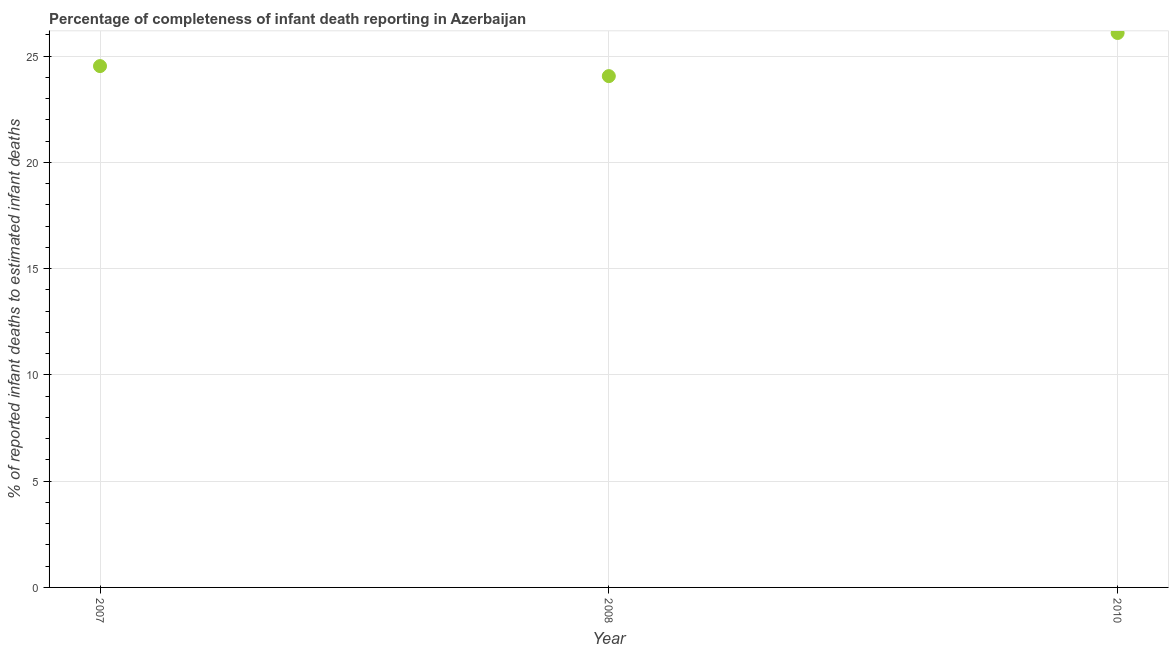What is the completeness of infant death reporting in 2007?
Your answer should be compact. 24.53. Across all years, what is the maximum completeness of infant death reporting?
Ensure brevity in your answer.  26.09. Across all years, what is the minimum completeness of infant death reporting?
Give a very brief answer. 24.06. What is the sum of the completeness of infant death reporting?
Provide a succinct answer. 74.68. What is the difference between the completeness of infant death reporting in 2007 and 2010?
Offer a terse response. -1.56. What is the average completeness of infant death reporting per year?
Your answer should be very brief. 24.89. What is the median completeness of infant death reporting?
Offer a very short reply. 24.53. What is the ratio of the completeness of infant death reporting in 2007 to that in 2008?
Your response must be concise. 1.02. Is the difference between the completeness of infant death reporting in 2008 and 2010 greater than the difference between any two years?
Keep it short and to the point. Yes. What is the difference between the highest and the second highest completeness of infant death reporting?
Provide a succinct answer. 1.56. What is the difference between the highest and the lowest completeness of infant death reporting?
Keep it short and to the point. 2.03. How many dotlines are there?
Give a very brief answer. 1. What is the difference between two consecutive major ticks on the Y-axis?
Ensure brevity in your answer.  5. Are the values on the major ticks of Y-axis written in scientific E-notation?
Your response must be concise. No. Does the graph contain grids?
Offer a very short reply. Yes. What is the title of the graph?
Provide a succinct answer. Percentage of completeness of infant death reporting in Azerbaijan. What is the label or title of the Y-axis?
Your answer should be compact. % of reported infant deaths to estimated infant deaths. What is the % of reported infant deaths to estimated infant deaths in 2007?
Your answer should be very brief. 24.53. What is the % of reported infant deaths to estimated infant deaths in 2008?
Your answer should be very brief. 24.06. What is the % of reported infant deaths to estimated infant deaths in 2010?
Your answer should be very brief. 26.09. What is the difference between the % of reported infant deaths to estimated infant deaths in 2007 and 2008?
Your answer should be compact. 0.47. What is the difference between the % of reported infant deaths to estimated infant deaths in 2007 and 2010?
Offer a terse response. -1.56. What is the difference between the % of reported infant deaths to estimated infant deaths in 2008 and 2010?
Offer a terse response. -2.03. What is the ratio of the % of reported infant deaths to estimated infant deaths in 2007 to that in 2008?
Offer a terse response. 1.02. What is the ratio of the % of reported infant deaths to estimated infant deaths in 2007 to that in 2010?
Offer a very short reply. 0.94. What is the ratio of the % of reported infant deaths to estimated infant deaths in 2008 to that in 2010?
Keep it short and to the point. 0.92. 